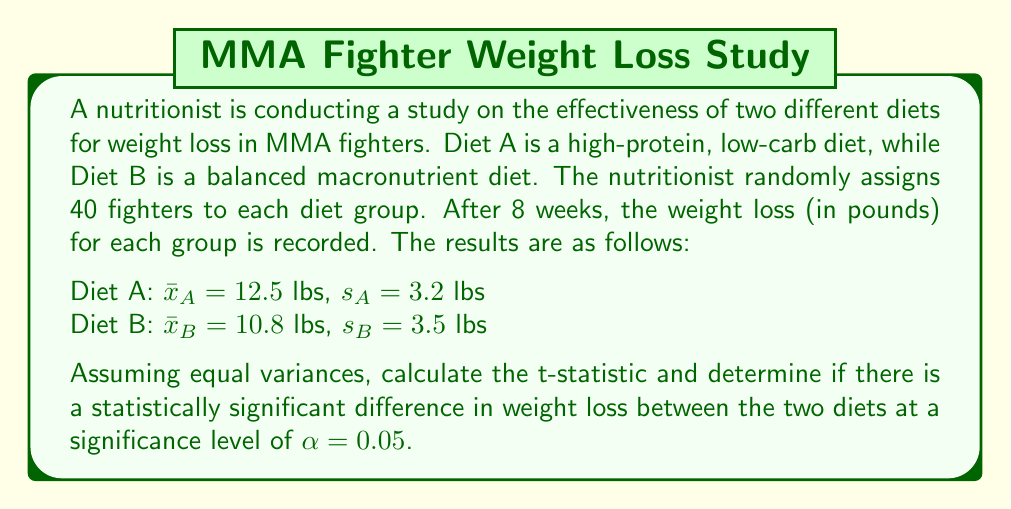Solve this math problem. To determine if there is a statistically significant difference in weight loss between the two diets, we need to perform a two-sample t-test. We'll follow these steps:

1. Calculate the pooled standard deviation:
   $$s_p = \sqrt{\frac{(n_A - 1)s_A^2 + (n_B - 1)s_B^2}{n_A + n_B - 2}}$$
   
   Where $n_A = n_B = 40$
   
   $$s_p = \sqrt{\frac{(40 - 1)3.2^2 + (40 - 1)3.5^2}{40 + 40 - 2}} = \sqrt{\frac{39 \cdot 10.24 + 39 \cdot 12.25}{78}} = 3.35$$

2. Calculate the standard error of the difference between means:
   $$SE = s_p \sqrt{\frac{1}{n_A} + \frac{1}{n_B}} = 3.35 \sqrt{\frac{1}{40} + \frac{1}{40}} = 0.75$$

3. Calculate the t-statistic:
   $$t = \frac{\bar{x}_A - \bar{x}_B}{SE} = \frac{12.5 - 10.8}{0.75} = 2.27$$

4. Determine the degrees of freedom:
   $df = n_A + n_B - 2 = 40 + 40 - 2 = 78$

5. Find the critical t-value for a two-tailed test at $\alpha = 0.05$ and $df = 78$:
   $t_{critical} = \pm 1.991$ (from t-distribution table)

6. Compare the calculated t-statistic to the critical t-value:
   Since $|2.27| > 1.991$, we reject the null hypothesis.

Therefore, there is a statistically significant difference in weight loss between the two diets at a significance level of 0.05.
Answer: The t-statistic is 2.27, which is greater than the critical t-value of 1.991. Therefore, there is a statistically significant difference in weight loss between the two diets at a significance level of 0.05. 